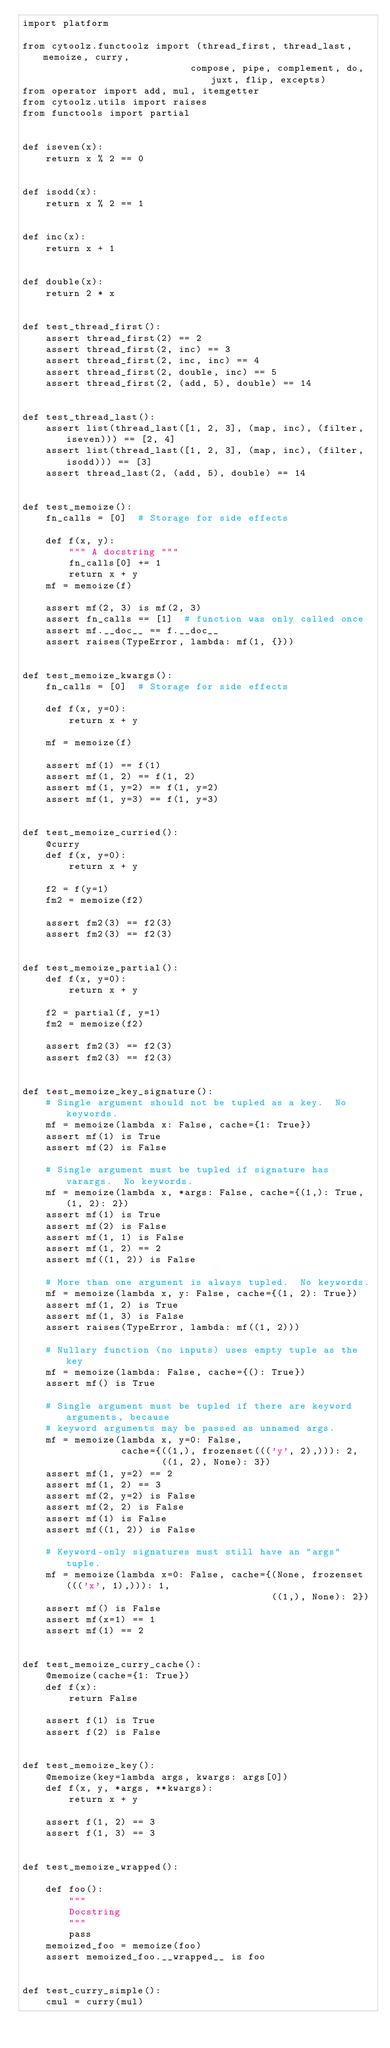<code> <loc_0><loc_0><loc_500><loc_500><_Python_>import platform

from cytoolz.functoolz import (thread_first, thread_last, memoize, curry,
                             compose, pipe, complement, do, juxt, flip, excepts)
from operator import add, mul, itemgetter
from cytoolz.utils import raises
from functools import partial


def iseven(x):
    return x % 2 == 0


def isodd(x):
    return x % 2 == 1


def inc(x):
    return x + 1


def double(x):
    return 2 * x


def test_thread_first():
    assert thread_first(2) == 2
    assert thread_first(2, inc) == 3
    assert thread_first(2, inc, inc) == 4
    assert thread_first(2, double, inc) == 5
    assert thread_first(2, (add, 5), double) == 14


def test_thread_last():
    assert list(thread_last([1, 2, 3], (map, inc), (filter, iseven))) == [2, 4]
    assert list(thread_last([1, 2, 3], (map, inc), (filter, isodd))) == [3]
    assert thread_last(2, (add, 5), double) == 14


def test_memoize():
    fn_calls = [0]  # Storage for side effects

    def f(x, y):
        """ A docstring """
        fn_calls[0] += 1
        return x + y
    mf = memoize(f)

    assert mf(2, 3) is mf(2, 3)
    assert fn_calls == [1]  # function was only called once
    assert mf.__doc__ == f.__doc__
    assert raises(TypeError, lambda: mf(1, {}))


def test_memoize_kwargs():
    fn_calls = [0]  # Storage for side effects

    def f(x, y=0):
        return x + y

    mf = memoize(f)

    assert mf(1) == f(1)
    assert mf(1, 2) == f(1, 2)
    assert mf(1, y=2) == f(1, y=2)
    assert mf(1, y=3) == f(1, y=3)


def test_memoize_curried():
    @curry
    def f(x, y=0):
        return x + y

    f2 = f(y=1)
    fm2 = memoize(f2)

    assert fm2(3) == f2(3)
    assert fm2(3) == f2(3)


def test_memoize_partial():
    def f(x, y=0):
        return x + y

    f2 = partial(f, y=1)
    fm2 = memoize(f2)

    assert fm2(3) == f2(3)
    assert fm2(3) == f2(3)


def test_memoize_key_signature():
    # Single argument should not be tupled as a key.  No keywords.
    mf = memoize(lambda x: False, cache={1: True})
    assert mf(1) is True
    assert mf(2) is False

    # Single argument must be tupled if signature has varargs.  No keywords.
    mf = memoize(lambda x, *args: False, cache={(1,): True, (1, 2): 2})
    assert mf(1) is True
    assert mf(2) is False
    assert mf(1, 1) is False
    assert mf(1, 2) == 2
    assert mf((1, 2)) is False

    # More than one argument is always tupled.  No keywords.
    mf = memoize(lambda x, y: False, cache={(1, 2): True})
    assert mf(1, 2) is True
    assert mf(1, 3) is False
    assert raises(TypeError, lambda: mf((1, 2)))

    # Nullary function (no inputs) uses empty tuple as the key
    mf = memoize(lambda: False, cache={(): True})
    assert mf() is True

    # Single argument must be tupled if there are keyword arguments, because
    # keyword arguments may be passed as unnamed args.
    mf = memoize(lambda x, y=0: False,
                 cache={((1,), frozenset((('y', 2),))): 2,
                        ((1, 2), None): 3})
    assert mf(1, y=2) == 2
    assert mf(1, 2) == 3
    assert mf(2, y=2) is False
    assert mf(2, 2) is False
    assert mf(1) is False
    assert mf((1, 2)) is False

    # Keyword-only signatures must still have an "args" tuple.
    mf = memoize(lambda x=0: False, cache={(None, frozenset((('x', 1),))): 1,
                                           ((1,), None): 2})
    assert mf() is False
    assert mf(x=1) == 1
    assert mf(1) == 2


def test_memoize_curry_cache():
    @memoize(cache={1: True})
    def f(x):
        return False

    assert f(1) is True
    assert f(2) is False


def test_memoize_key():
    @memoize(key=lambda args, kwargs: args[0])
    def f(x, y, *args, **kwargs):
        return x + y

    assert f(1, 2) == 3
    assert f(1, 3) == 3


def test_memoize_wrapped():

    def foo():
        """
        Docstring
        """
        pass
    memoized_foo = memoize(foo)
    assert memoized_foo.__wrapped__ is foo


def test_curry_simple():
    cmul = curry(mul)</code> 